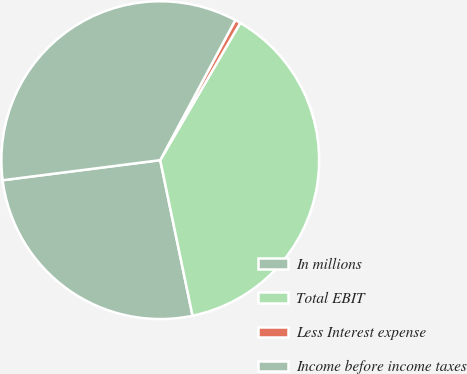Convert chart. <chart><loc_0><loc_0><loc_500><loc_500><pie_chart><fcel>In millions<fcel>Total EBIT<fcel>Less Interest expense<fcel>Income before income taxes<nl><fcel>26.24%<fcel>38.34%<fcel>0.57%<fcel>34.85%<nl></chart> 